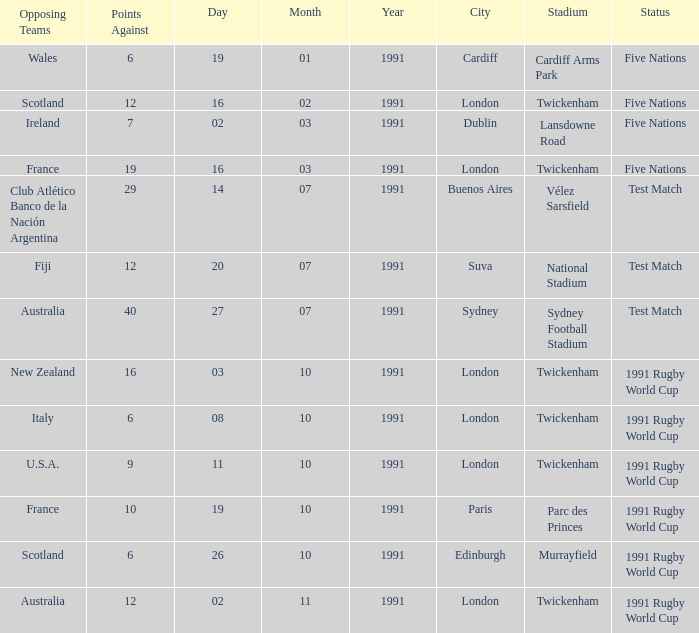What is Against, when Opposing Teams is "Australia", and when Date is "27/07/1991"? 40.0. 